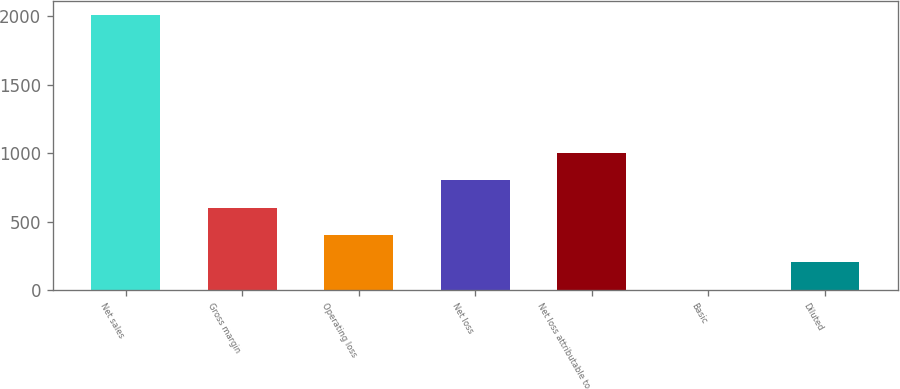Convert chart. <chart><loc_0><loc_0><loc_500><loc_500><bar_chart><fcel>Net sales<fcel>Gross margin<fcel>Operating loss<fcel>Net loss<fcel>Net loss attributable to<fcel>Basic<fcel>Diluted<nl><fcel>2009<fcel>602.9<fcel>402.03<fcel>803.77<fcel>1004.64<fcel>0.29<fcel>201.16<nl></chart> 